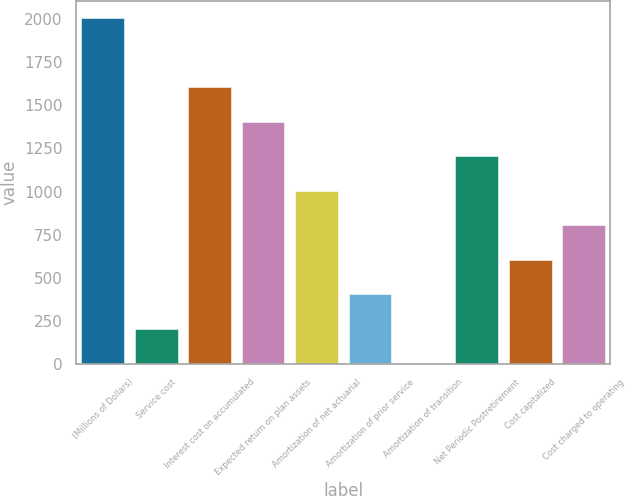<chart> <loc_0><loc_0><loc_500><loc_500><bar_chart><fcel>(Millions of Dollars)<fcel>Service cost<fcel>Interest cost on accumulated<fcel>Expected return on plan assets<fcel>Amortization of net actuarial<fcel>Amortization of prior service<fcel>Amortization of transition<fcel>Net Periodic Postretirement<fcel>Cost capitalized<fcel>Cost charged to operating<nl><fcel>2005<fcel>204.1<fcel>1604.8<fcel>1404.7<fcel>1004.5<fcel>404.2<fcel>4<fcel>1204.6<fcel>604.3<fcel>804.4<nl></chart> 